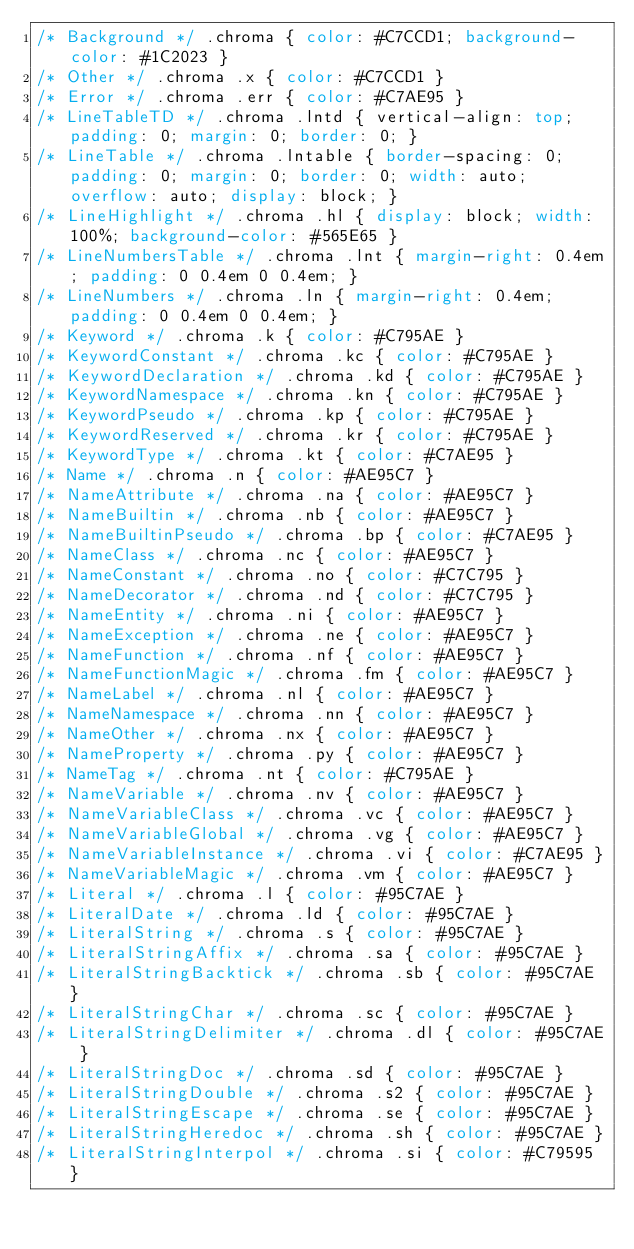Convert code to text. <code><loc_0><loc_0><loc_500><loc_500><_CSS_>/* Background */ .chroma { color: #C7CCD1; background-color: #1C2023 }
/* Other */ .chroma .x { color: #C7CCD1 }
/* Error */ .chroma .err { color: #C7AE95 }
/* LineTableTD */ .chroma .lntd { vertical-align: top; padding: 0; margin: 0; border: 0; }
/* LineTable */ .chroma .lntable { border-spacing: 0; padding: 0; margin: 0; border: 0; width: auto; overflow: auto; display: block; }
/* LineHighlight */ .chroma .hl { display: block; width: 100%; background-color: #565E65 }
/* LineNumbersTable */ .chroma .lnt { margin-right: 0.4em; padding: 0 0.4em 0 0.4em; }
/* LineNumbers */ .chroma .ln { margin-right: 0.4em; padding: 0 0.4em 0 0.4em; }
/* Keyword */ .chroma .k { color: #C795AE }
/* KeywordConstant */ .chroma .kc { color: #C795AE }
/* KeywordDeclaration */ .chroma .kd { color: #C795AE }
/* KeywordNamespace */ .chroma .kn { color: #C795AE }
/* KeywordPseudo */ .chroma .kp { color: #C795AE }
/* KeywordReserved */ .chroma .kr { color: #C795AE }
/* KeywordType */ .chroma .kt { color: #C7AE95 }
/* Name */ .chroma .n { color: #AE95C7 }
/* NameAttribute */ .chroma .na { color: #AE95C7 }
/* NameBuiltin */ .chroma .nb { color: #AE95C7 }
/* NameBuiltinPseudo */ .chroma .bp { color: #C7AE95 }
/* NameClass */ .chroma .nc { color: #AE95C7 }
/* NameConstant */ .chroma .no { color: #C7C795 }
/* NameDecorator */ .chroma .nd { color: #C7C795 }
/* NameEntity */ .chroma .ni { color: #AE95C7 }
/* NameException */ .chroma .ne { color: #AE95C7 }
/* NameFunction */ .chroma .nf { color: #AE95C7 }
/* NameFunctionMagic */ .chroma .fm { color: #AE95C7 }
/* NameLabel */ .chroma .nl { color: #AE95C7 }
/* NameNamespace */ .chroma .nn { color: #AE95C7 }
/* NameOther */ .chroma .nx { color: #AE95C7 }
/* NameProperty */ .chroma .py { color: #AE95C7 }
/* NameTag */ .chroma .nt { color: #C795AE }
/* NameVariable */ .chroma .nv { color: #AE95C7 }
/* NameVariableClass */ .chroma .vc { color: #AE95C7 }
/* NameVariableGlobal */ .chroma .vg { color: #AE95C7 }
/* NameVariableInstance */ .chroma .vi { color: #C7AE95 }
/* NameVariableMagic */ .chroma .vm { color: #AE95C7 }
/* Literal */ .chroma .l { color: #95C7AE }
/* LiteralDate */ .chroma .ld { color: #95C7AE }
/* LiteralString */ .chroma .s { color: #95C7AE }
/* LiteralStringAffix */ .chroma .sa { color: #95C7AE }
/* LiteralStringBacktick */ .chroma .sb { color: #95C7AE }
/* LiteralStringChar */ .chroma .sc { color: #95C7AE }
/* LiteralStringDelimiter */ .chroma .dl { color: #95C7AE }
/* LiteralStringDoc */ .chroma .sd { color: #95C7AE }
/* LiteralStringDouble */ .chroma .s2 { color: #95C7AE }
/* LiteralStringEscape */ .chroma .se { color: #95C7AE }
/* LiteralStringHeredoc */ .chroma .sh { color: #95C7AE }
/* LiteralStringInterpol */ .chroma .si { color: #C79595 }</code> 